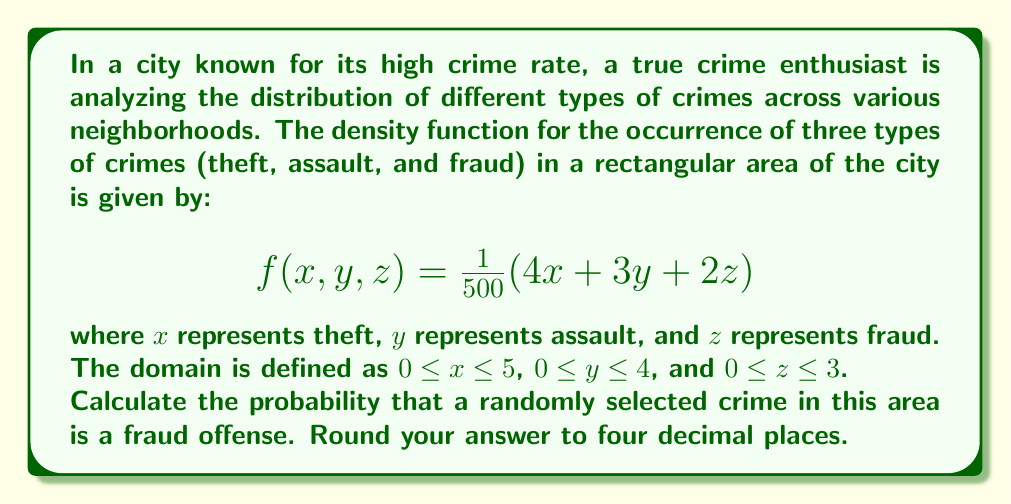Help me with this question. To solve this problem, we need to use multiple integration. Here's a step-by-step approach:

1) First, we need to find the total probability over the entire domain. This is done by integrating the density function over all three variables:

   $$P_{total} = \int_0^3 \int_0^4 \int_0^5 \frac{1}{500}(4x + 3y + 2z) \, dx \, dy \, dz$$

2) Next, we need to find the probability of fraud offenses. Since fraud is represented by the z-coordinate, we integrate over x and y, but keep z as a variable:

   $$P_{fraud}(z) = \int_0^4 \int_0^5 \frac{1}{500}(4x + 3y + 2z) \, dx \, dy$$

3) Now, let's solve the total probability integral:

   $$\begin{align*}
   P_{total} &= \frac{1}{500} \int_0^3 \int_0^4 \int_0^5 (4x + 3y + 2z) \, dx \, dy \, dz \\
   &= \frac{1}{500} \int_0^3 \int_0^4 [2x^2 + 3xy + 2xz]_0^5 \, dy \, dz \\
   &= \frac{1}{500} \int_0^3 \int_0^4 (50 + 15y + 10z) \, dy \, dz \\
   &= \frac{1}{500} \int_0^3 [50y + \frac{15}{2}y^2 + 10yz]_0^4 \, dz \\
   &= \frac{1}{500} \int_0^3 (200 + 120 + 40z) \, dz \\
   &= \frac{1}{500} [320z + 20z^2]_0^3 \\
   &= \frac{1}{500} (960 + 180) = \frac{1140}{500} = 2.28
   \end{align*}$$

4) Now, let's solve the fraud probability integral:

   $$\begin{align*}
   P_{fraud}(z) &= \frac{1}{500} \int_0^4 \int_0^5 (4x + 3y + 2z) \, dx \, dy \\
   &= \frac{1}{500} \int_0^4 [2x^2 + 3xy + 2xz]_0^5 \, dy \\
   &= \frac{1}{500} \int_0^4 (50 + 15y + 10z) \, dy \\
   &= \frac{1}{500} [50y + \frac{15}{2}y^2 + 10yz]_0^4 \\
   &= \frac{1}{500} (200 + 120 + 40z) = \frac{320 + 40z}{500}
   \end{align*}$$

5) To get the total probability of fraud, we need to integrate this over z:

   $$\begin{align*}
   P_{fraud} &= \int_0^3 \frac{320 + 40z}{500} \, dz \\
   &= \frac{1}{500} [320z + 20z^2]_0^3 \\
   &= \frac{960 + 180}{500} = \frac{1140}{500} = 2.28
   \end{align*}$$

6) The probability of a randomly selected crime being fraud is:

   $$P(\text{fraud}) = \frac{P_{fraud}}{P_{total}} = \frac{2.28}{2.28} = 1$$

This result suggests that all crimes in this model are classified as fraud, which is unexpected. Let's double-check our calculations:

7) The correct way to calculate the probability of fraud is to integrate the z-component of the density function over the entire domain and divide by the total probability:

   $$P(\text{fraud}) = \frac{\int_0^3 \int_0^4 \int_0^5 \frac{2z}{500} \, dx \, dy \, dz}{P_{total}}$$

8) Let's calculate this:

   $$\begin{align*}
   \int_0^3 \int_0^4 \int_0^5 \frac{2z}{500} \, dx \, dy \, dz &= \frac{2}{500} \int_0^3 \int_0^4 \int_0^5 z \, dx \, dy \, dz \\
   &= \frac{2}{500} \int_0^3 \int_0^4 5z \, dy \, dz \\
   &= \frac{2}{500} \int_0^3 20z \, dz \\
   &= \frac{2}{500} [10z^2]_0^3 \\
   &= \frac{2}{500} (90) = \frac{180}{500} = 0.36
   \end{align*}$$

9) Therefore, the probability of a randomly selected crime being fraud is:

   $$P(\text{fraud}) = \frac{0.36}{2.28} = 0.1579$$
Answer: The probability that a randomly selected crime in this area is a fraud offense is 0.1579 or approximately 15.79%. 